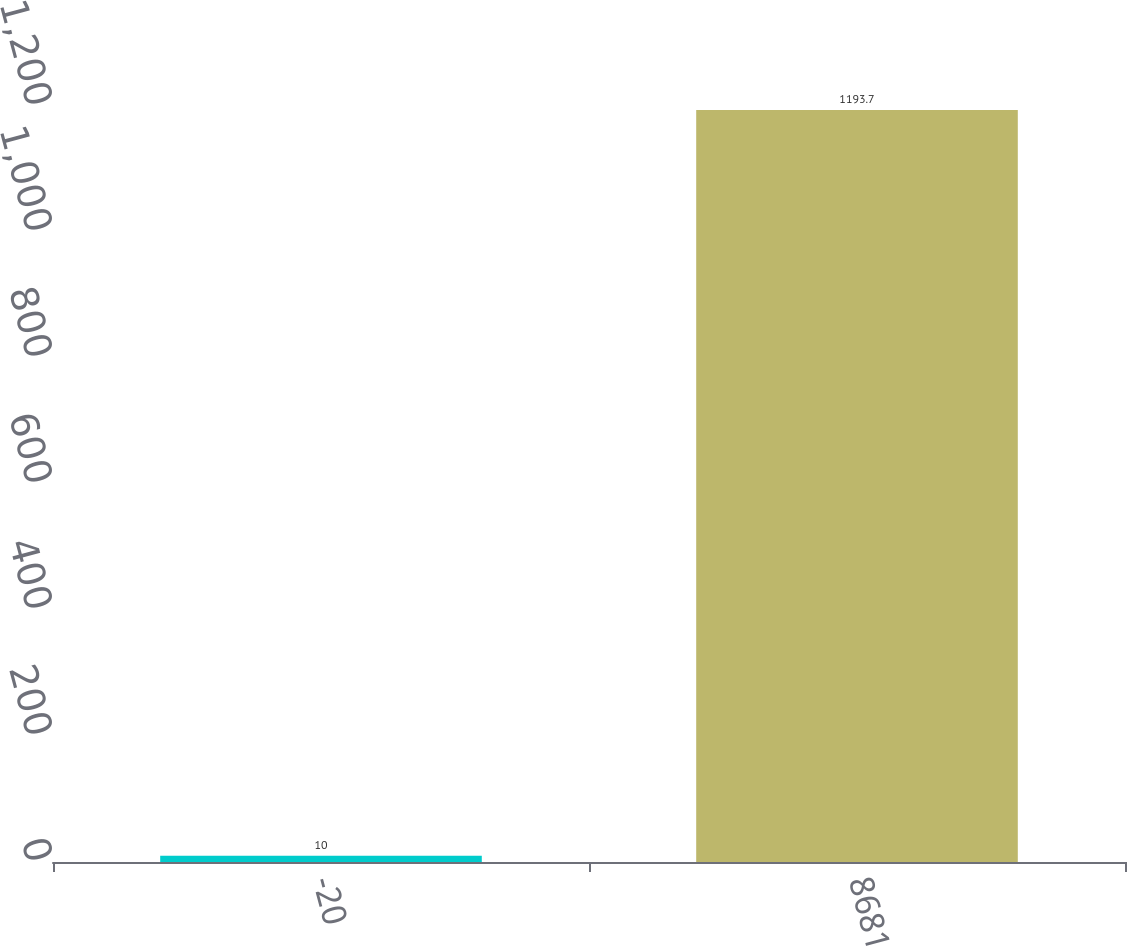<chart> <loc_0><loc_0><loc_500><loc_500><bar_chart><fcel>-20<fcel>8681<nl><fcel>10<fcel>1193.7<nl></chart> 